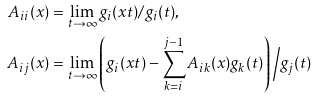Convert formula to latex. <formula><loc_0><loc_0><loc_500><loc_500>A _ { i i } ( x ) & = \lim _ { t \to \infty } g _ { i } ( x t ) / g _ { i } ( t ) , \\ A _ { i j } ( x ) & = \lim _ { t \to \infty } \left ( g _ { i } ( x t ) - \sum _ { k = i } ^ { j - 1 } A _ { i k } ( x ) g _ { k } ( t ) \right ) \Big / g _ { j } ( t )</formula> 